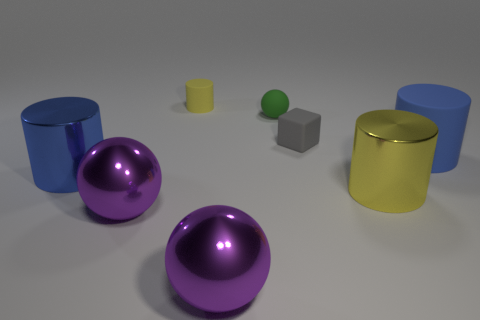Subtract all yellow balls. How many blue cylinders are left? 2 Subtract all big shiny balls. How many balls are left? 1 Add 1 green spheres. How many objects exist? 9 Subtract all blue balls. Subtract all yellow cylinders. How many balls are left? 3 Subtract all cubes. How many objects are left? 7 Subtract all big matte things. Subtract all big cylinders. How many objects are left? 4 Add 7 blue metal cylinders. How many blue metal cylinders are left? 8 Add 8 large blue cubes. How many large blue cubes exist? 8 Subtract 0 cyan blocks. How many objects are left? 8 